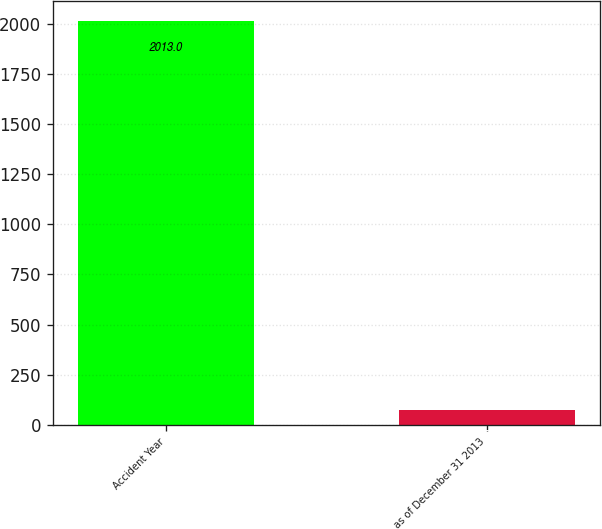Convert chart. <chart><loc_0><loc_0><loc_500><loc_500><bar_chart><fcel>Accident Year<fcel>as of December 31 2013<nl><fcel>2013<fcel>75.4<nl></chart> 